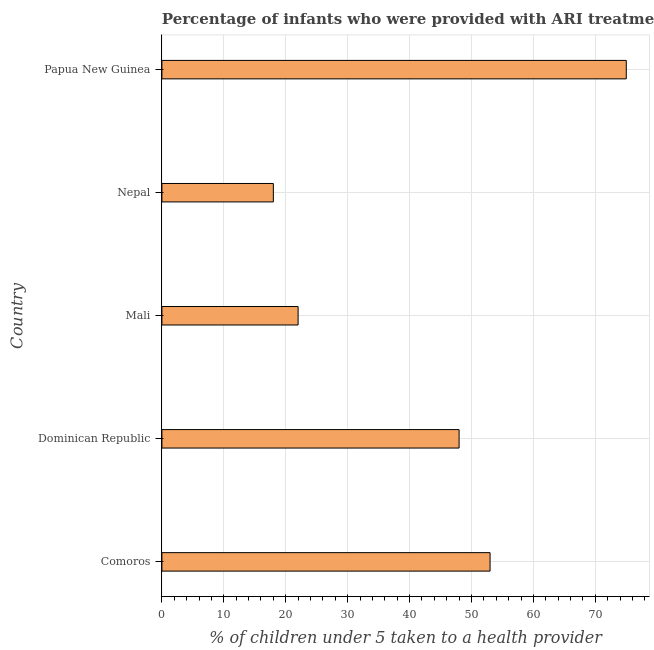Does the graph contain grids?
Your answer should be compact. Yes. What is the title of the graph?
Provide a short and direct response. Percentage of infants who were provided with ARI treatment in the year 1996. What is the label or title of the X-axis?
Offer a very short reply. % of children under 5 taken to a health provider. What is the percentage of children who were provided with ari treatment in Comoros?
Make the answer very short. 53. Across all countries, what is the maximum percentage of children who were provided with ari treatment?
Give a very brief answer. 75. Across all countries, what is the minimum percentage of children who were provided with ari treatment?
Offer a terse response. 18. In which country was the percentage of children who were provided with ari treatment maximum?
Your answer should be very brief. Papua New Guinea. In which country was the percentage of children who were provided with ari treatment minimum?
Offer a terse response. Nepal. What is the sum of the percentage of children who were provided with ari treatment?
Your response must be concise. 216. What is the median percentage of children who were provided with ari treatment?
Offer a terse response. 48. What is the ratio of the percentage of children who were provided with ari treatment in Mali to that in Nepal?
Provide a short and direct response. 1.22. Is the percentage of children who were provided with ari treatment in Comoros less than that in Dominican Republic?
Your response must be concise. No. What is the difference between the highest and the second highest percentage of children who were provided with ari treatment?
Provide a short and direct response. 22. Is the sum of the percentage of children who were provided with ari treatment in Comoros and Nepal greater than the maximum percentage of children who were provided with ari treatment across all countries?
Make the answer very short. No. What is the difference between the highest and the lowest percentage of children who were provided with ari treatment?
Your answer should be compact. 57. How many bars are there?
Your response must be concise. 5. Are all the bars in the graph horizontal?
Your answer should be compact. Yes. How many countries are there in the graph?
Your answer should be very brief. 5. What is the % of children under 5 taken to a health provider of Comoros?
Offer a very short reply. 53. What is the % of children under 5 taken to a health provider of Dominican Republic?
Your response must be concise. 48. What is the % of children under 5 taken to a health provider of Mali?
Ensure brevity in your answer.  22. What is the % of children under 5 taken to a health provider of Nepal?
Provide a short and direct response. 18. What is the difference between the % of children under 5 taken to a health provider in Comoros and Dominican Republic?
Make the answer very short. 5. What is the difference between the % of children under 5 taken to a health provider in Comoros and Mali?
Provide a short and direct response. 31. What is the difference between the % of children under 5 taken to a health provider in Comoros and Papua New Guinea?
Offer a terse response. -22. What is the difference between the % of children under 5 taken to a health provider in Dominican Republic and Mali?
Make the answer very short. 26. What is the difference between the % of children under 5 taken to a health provider in Dominican Republic and Nepal?
Offer a very short reply. 30. What is the difference between the % of children under 5 taken to a health provider in Mali and Nepal?
Keep it short and to the point. 4. What is the difference between the % of children under 5 taken to a health provider in Mali and Papua New Guinea?
Keep it short and to the point. -53. What is the difference between the % of children under 5 taken to a health provider in Nepal and Papua New Guinea?
Your response must be concise. -57. What is the ratio of the % of children under 5 taken to a health provider in Comoros to that in Dominican Republic?
Provide a short and direct response. 1.1. What is the ratio of the % of children under 5 taken to a health provider in Comoros to that in Mali?
Keep it short and to the point. 2.41. What is the ratio of the % of children under 5 taken to a health provider in Comoros to that in Nepal?
Your response must be concise. 2.94. What is the ratio of the % of children under 5 taken to a health provider in Comoros to that in Papua New Guinea?
Provide a short and direct response. 0.71. What is the ratio of the % of children under 5 taken to a health provider in Dominican Republic to that in Mali?
Your answer should be compact. 2.18. What is the ratio of the % of children under 5 taken to a health provider in Dominican Republic to that in Nepal?
Provide a short and direct response. 2.67. What is the ratio of the % of children under 5 taken to a health provider in Dominican Republic to that in Papua New Guinea?
Offer a terse response. 0.64. What is the ratio of the % of children under 5 taken to a health provider in Mali to that in Nepal?
Your response must be concise. 1.22. What is the ratio of the % of children under 5 taken to a health provider in Mali to that in Papua New Guinea?
Your response must be concise. 0.29. What is the ratio of the % of children under 5 taken to a health provider in Nepal to that in Papua New Guinea?
Offer a very short reply. 0.24. 